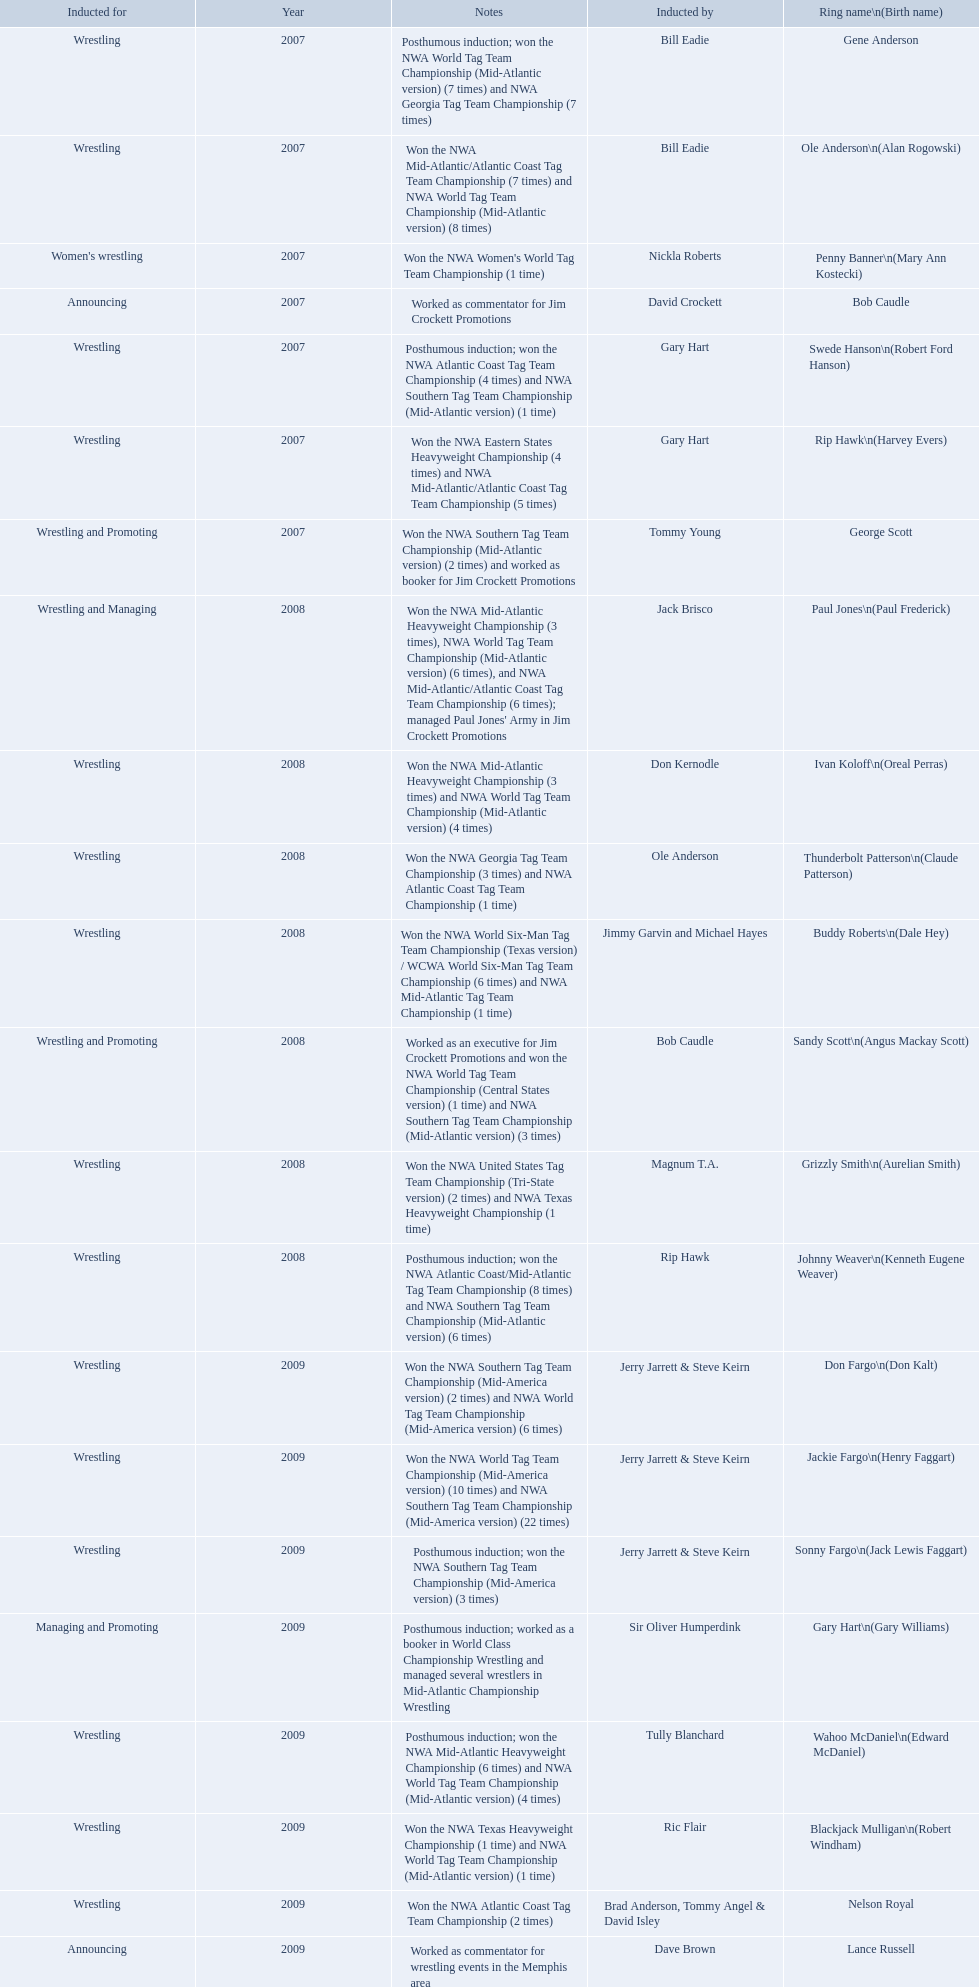What year was the induction held? 2007. Which inductee was not alive? Gene Anderson. Find the word(s) posthumous in the notes column. Posthumous induction; won the NWA World Tag Team Championship (Mid-Atlantic version) (7 times) and NWA Georgia Tag Team Championship (7 times), Posthumous induction; won the NWA Atlantic Coast Tag Team Championship (4 times) and NWA Southern Tag Team Championship (Mid-Atlantic version) (1 time), Posthumous induction; won the NWA Atlantic Coast/Mid-Atlantic Tag Team Championship (8 times) and NWA Southern Tag Team Championship (Mid-Atlantic version) (6 times), Posthumous induction; won the NWA Southern Tag Team Championship (Mid-America version) (3 times), Posthumous induction; worked as a booker in World Class Championship Wrestling and managed several wrestlers in Mid-Atlantic Championship Wrestling, Posthumous induction; won the NWA Mid-Atlantic Heavyweight Championship (6 times) and NWA World Tag Team Championship (Mid-Atlantic version) (4 times). What is the earliest year in the table that wrestlers were inducted? 2007, 2007, 2007, 2007, 2007, 2007, 2007. Find the wrestlers that wrestled underneath their birth name in the earliest year of induction. Gene Anderson, Bob Caudle, George Scott. Of the wrestlers who wrestled underneath their birth name in the earliest year of induction was one of them inducted posthumously? Gene Anderson. 